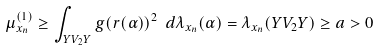<formula> <loc_0><loc_0><loc_500><loc_500>\mu _ { x _ { n } } ^ { ( 1 ) } \geq \int _ { Y V _ { 2 } Y } g ( r ( \alpha ) ) ^ { 2 } \ d \lambda _ { x _ { n } } ( \alpha ) = \lambda _ { x _ { n } } ( Y V _ { 2 } Y ) \geq a > 0</formula> 